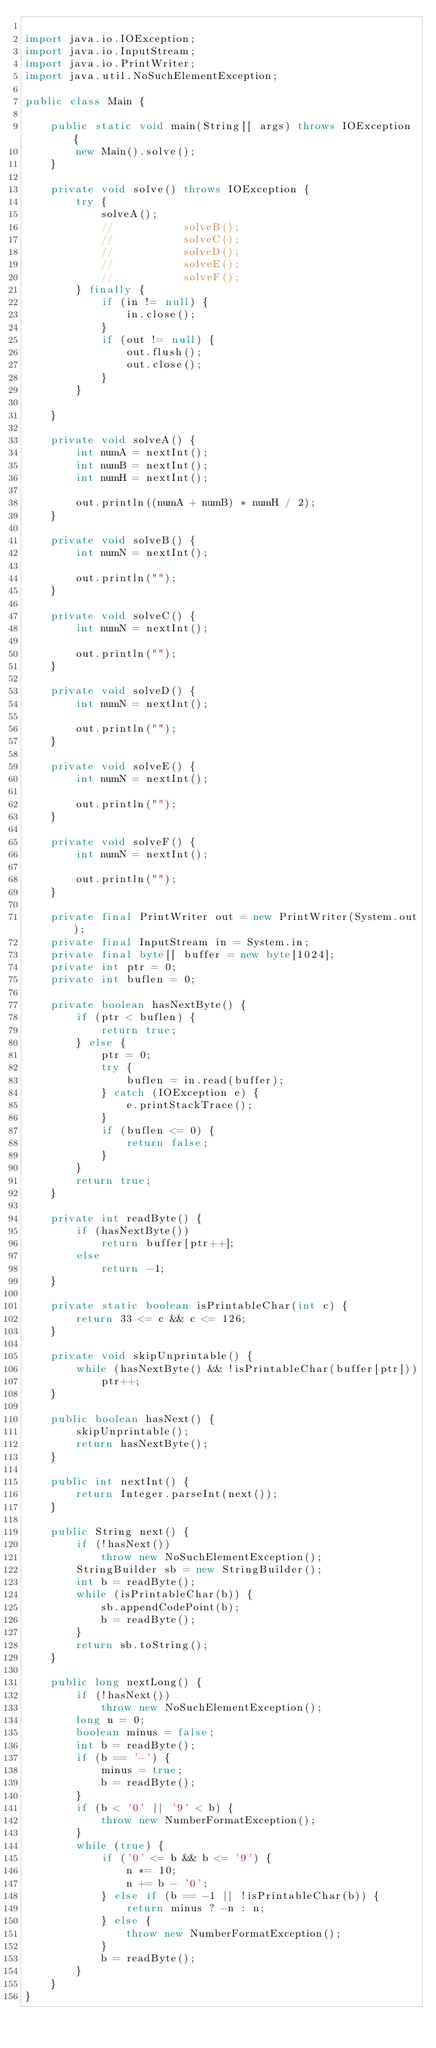Convert code to text. <code><loc_0><loc_0><loc_500><loc_500><_Java_>
import java.io.IOException;
import java.io.InputStream;
import java.io.PrintWriter;
import java.util.NoSuchElementException;

public class Main {

	public static void main(String[] args) throws IOException {
		new Main().solve();
	}

	private void solve() throws IOException {
		try {
			solveA();
			//			 solveB();
			//			 solveC();
			//			 solveD();
			//			 solveE();
			//			 solveF();
		} finally {
			if (in != null) {
				in.close();
			}
			if (out != null) {
				out.flush();
				out.close();
			}
		}

	}

	private void solveA() {
		int numA = nextInt();
		int numB = nextInt();
		int numH = nextInt();

		out.println((numA + numB) * numH / 2);
	}

	private void solveB() {
		int numN = nextInt();

		out.println("");
	}

	private void solveC() {
		int numN = nextInt();

		out.println("");
	}

	private void solveD() {
		int numN = nextInt();

		out.println("");
	}

	private void solveE() {
		int numN = nextInt();

		out.println("");
	}

	private void solveF() {
		int numN = nextInt();

		out.println("");
	}

	private final PrintWriter out = new PrintWriter(System.out);
	private final InputStream in = System.in;
	private final byte[] buffer = new byte[1024];
	private int ptr = 0;
	private int buflen = 0;

	private boolean hasNextByte() {
		if (ptr < buflen) {
			return true;
		} else {
			ptr = 0;
			try {
				buflen = in.read(buffer);
			} catch (IOException e) {
				e.printStackTrace();
			}
			if (buflen <= 0) {
				return false;
			}
		}
		return true;
	}

	private int readByte() {
		if (hasNextByte())
			return buffer[ptr++];
		else
			return -1;
	}

	private static boolean isPrintableChar(int c) {
		return 33 <= c && c <= 126;
	}

	private void skipUnprintable() {
		while (hasNextByte() && !isPrintableChar(buffer[ptr]))
			ptr++;
	}

	public boolean hasNext() {
		skipUnprintable();
		return hasNextByte();
	}

	public int nextInt() {
		return Integer.parseInt(next());
	}

	public String next() {
		if (!hasNext())
			throw new NoSuchElementException();
		StringBuilder sb = new StringBuilder();
		int b = readByte();
		while (isPrintableChar(b)) {
			sb.appendCodePoint(b);
			b = readByte();
		}
		return sb.toString();
	}

	public long nextLong() {
		if (!hasNext())
			throw new NoSuchElementException();
		long n = 0;
		boolean minus = false;
		int b = readByte();
		if (b == '-') {
			minus = true;
			b = readByte();
		}
		if (b < '0' || '9' < b) {
			throw new NumberFormatException();
		}
		while (true) {
			if ('0' <= b && b <= '9') {
				n *= 10;
				n += b - '0';
			} else if (b == -1 || !isPrintableChar(b)) {
				return minus ? -n : n;
			} else {
				throw new NumberFormatException();
			}
			b = readByte();
		}
	}
}</code> 